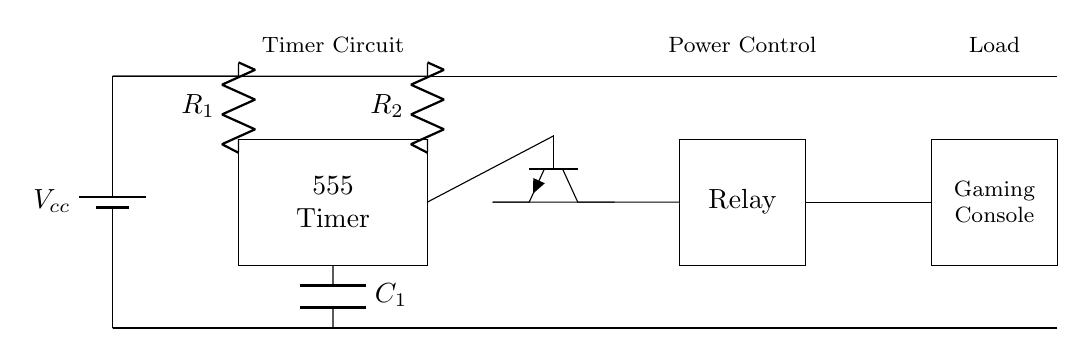What type of timer is used in this circuit? The timer used in the circuit is a 555 timer, which is indicated by the label on the rectangle representing it.
Answer: 555 timer What is the purpose of the relay in this circuit? The relay serves as a switch to control the power to the gaming console, allowing it to be turned off when the timer triggers after a set duration.
Answer: Power control How many resistors are shown in this circuit? There are two resistors present in the circuit, labeled R1 and R2, which are connected in series to the timer for setting the timing interval.
Answer: Two What component is used to store charge in this timer circuit? The component used for storing charge in this timer circuit is a capacitor, labeled C1, which is crucial for creating the delay before the console shuts off.
Answer: Capacitor What will happen to the gaming console after the timer reaches its duration? After the timer reaches its duration, it will trigger the relay to turn off the gaming console, effectively cutting its power supply.
Answer: It will shut off Which way is the transistor oriented in the circuit? The transistor is oriented with its emitter pointing downwards and its collector going towards the relay, indicating it is in a standard NPN configuration for switching.
Answer: Downwards 